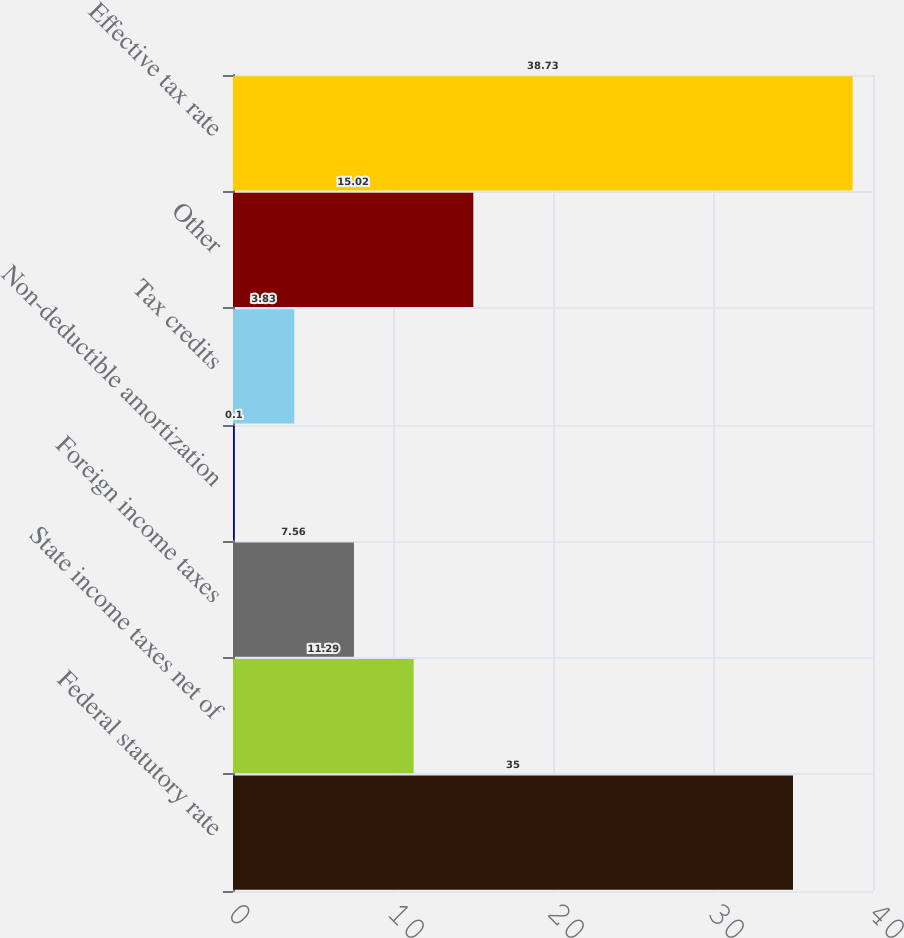Convert chart. <chart><loc_0><loc_0><loc_500><loc_500><bar_chart><fcel>Federal statutory rate<fcel>State income taxes net of<fcel>Foreign income taxes<fcel>Non-deductible amortization<fcel>Tax credits<fcel>Other<fcel>Effective tax rate<nl><fcel>35<fcel>11.29<fcel>7.56<fcel>0.1<fcel>3.83<fcel>15.02<fcel>38.73<nl></chart> 